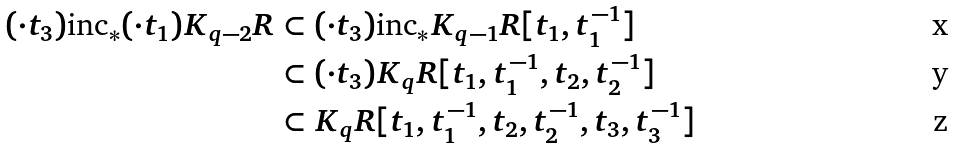<formula> <loc_0><loc_0><loc_500><loc_500>( \cdot t _ { 3 } ) \text {inc} _ { * } ( \cdot t _ { 1 } ) K _ { q - 2 } R & \subset ( \cdot t _ { 3 } ) \text {inc} _ { * } K _ { q - 1 } R [ t _ { 1 } , t _ { 1 } ^ { - 1 } ] \\ & \subset ( \cdot t _ { 3 } ) K _ { q } R [ t _ { 1 } , t _ { 1 } ^ { - 1 } , t _ { 2 } , t _ { 2 } ^ { - 1 } ] \\ & \subset K _ { q } R [ t _ { 1 } , t _ { 1 } ^ { - 1 } , t _ { 2 } , t _ { 2 } ^ { - 1 } , t _ { 3 } , t _ { 3 } ^ { - 1 } ]</formula> 